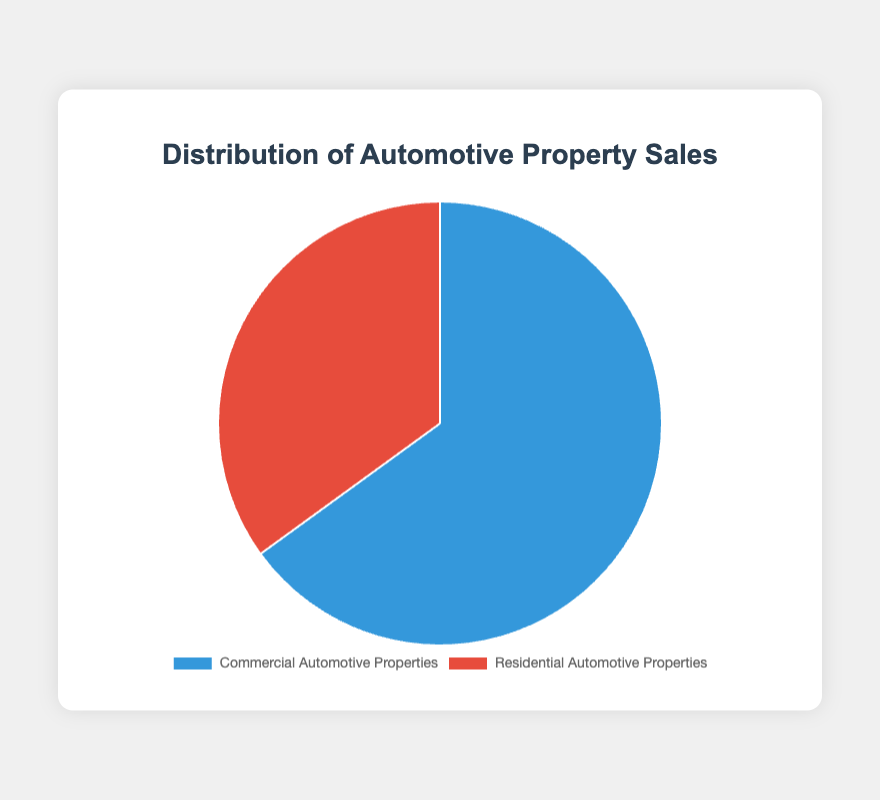What is the percentage of Commercial Automotive Properties sales? The chart indicates the data slices: one labeled "Commercial Automotive Properties" with a value of 65%. This number is explicitly noted.
Answer: 65% What is the percentage difference between Commercial and Residential Automotive Properties sales? From the chart, sales of Commercial Automotive Properties are 65% and Residential Automotive Properties are 35%. Subtracting 35% from 65%, the difference is 30%.
Answer: 30% Which type of property has the higher sales proportion? By examining the chart, the "Commercial Automotive Properties" segment is larger than the "Residential Automotive Properties" segment. "Commercial Automotive Properties" has 65%, while "Residential Automotive Properties" has 35%.
Answer: Commercial Automotive Properties What is the combined percentage of both Commercial and Residential Automotive Properties sales? The chart only shows two segments adding up to a total. Summing 65% for Commercial and 35% for Residential results in 100%. This validates that both properties together account for the entire dataset.
Answer: 100% By how much do the Commercial Automotive Properties sales exceed Residential Automotive Properties sales? The chart shows that Commercial sales are at 65% and Residential sales are at 35%. Subtracting 35% from 65% gives a difference of 30%.
Answer: 30% What color represents Residential Automotive Properties in the chart? Residential Automotive Properties are depicted with the color red, as demonstrated in the pie chart segment's visual appearance.
Answer: Red 